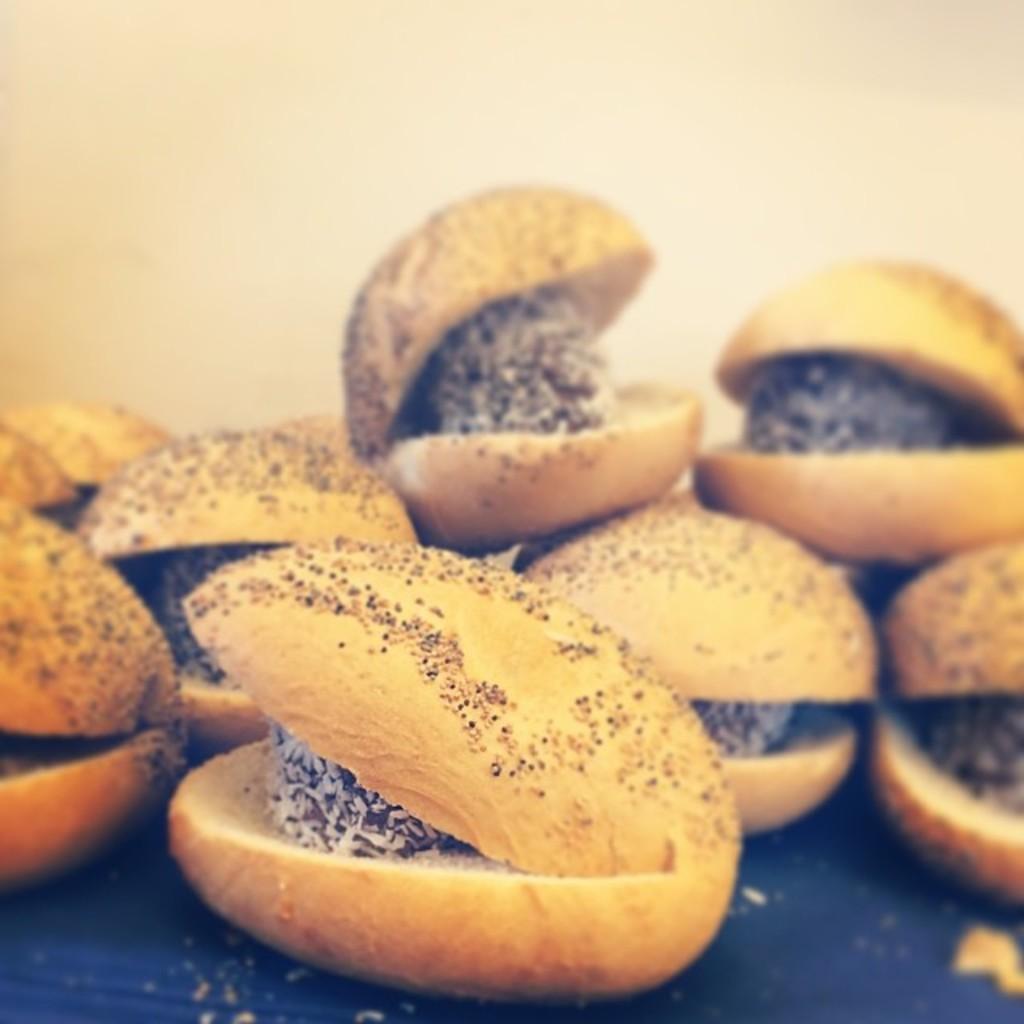How would you summarize this image in a sentence or two? In this picture we can see food on the blue surface. In the background of the image it is cream in color. 